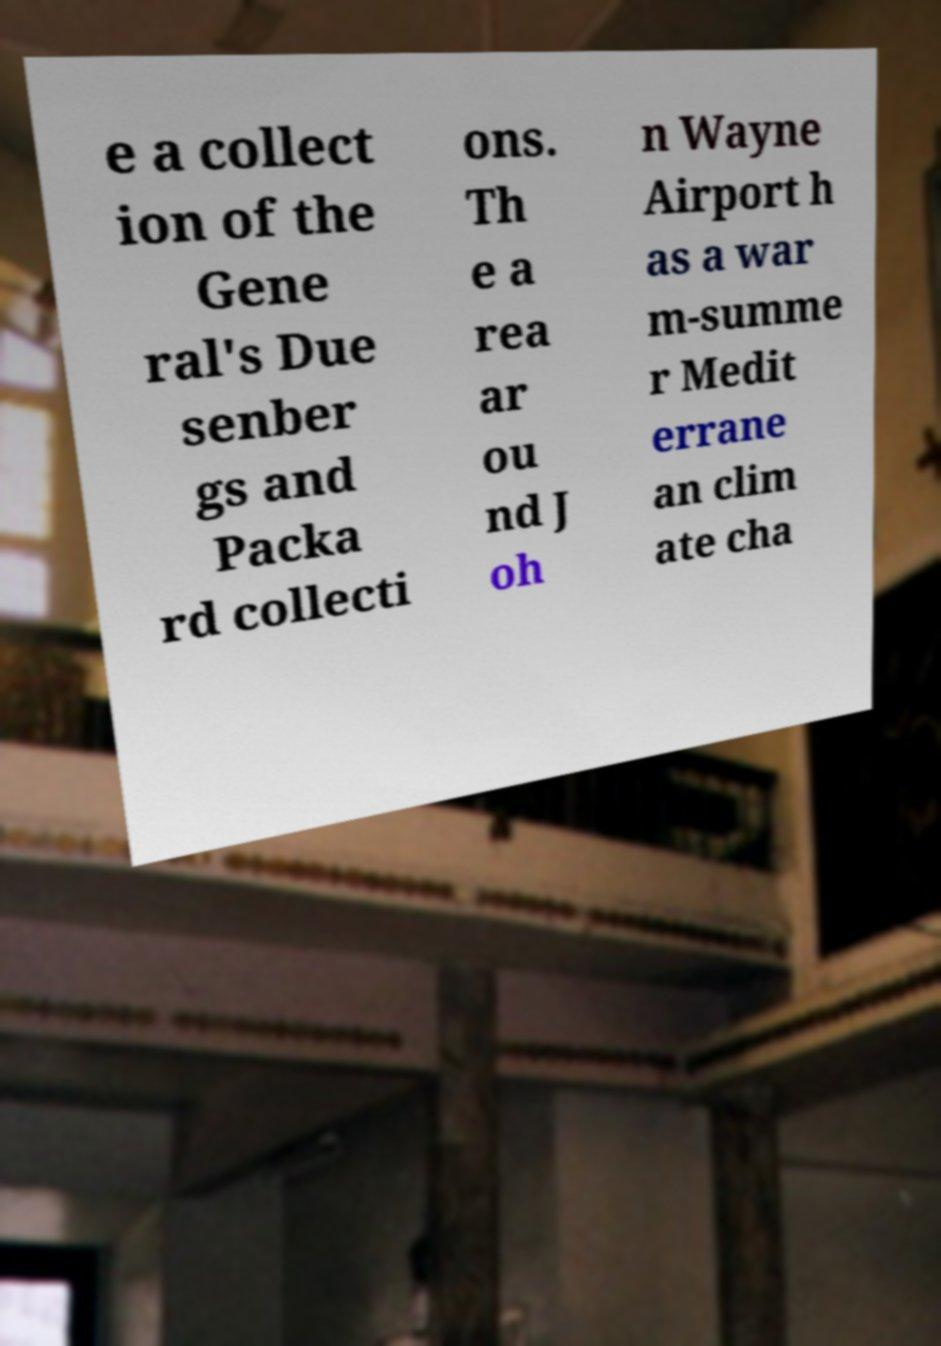For documentation purposes, I need the text within this image transcribed. Could you provide that? e a collect ion of the Gene ral's Due senber gs and Packa rd collecti ons. Th e a rea ar ou nd J oh n Wayne Airport h as a war m-summe r Medit errane an clim ate cha 